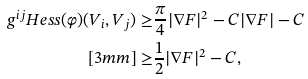<formula> <loc_0><loc_0><loc_500><loc_500>g ^ { i j } H e s s ( \varphi ) ( V _ { i } , V _ { j } ) \geq & \frac { \pi } { 4 } | \nabla F | ^ { 2 } - C | \nabla F | - C \\ [ 3 m m ] \geq & \frac { 1 } { 2 } | \nabla F | ^ { 2 } - C ,</formula> 